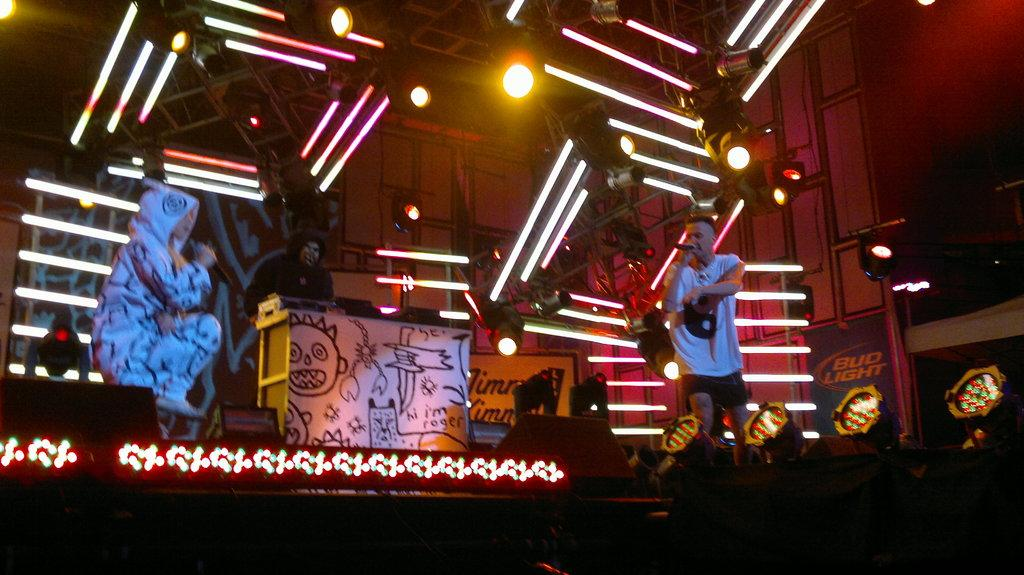How many people are in the group shown in the image? There is a group of people in the image, but the exact number is not specified. What are some people in the group doing? Some people in the group are holding microphones. What can be seen in the background of the image? There are musical instruments, lights, and metal rods in the background of the image. What type of watch is the person wearing in the image? There is no watch visible on any person in the image. Are there any trees present in the image? No, there are no trees visible in the image. 